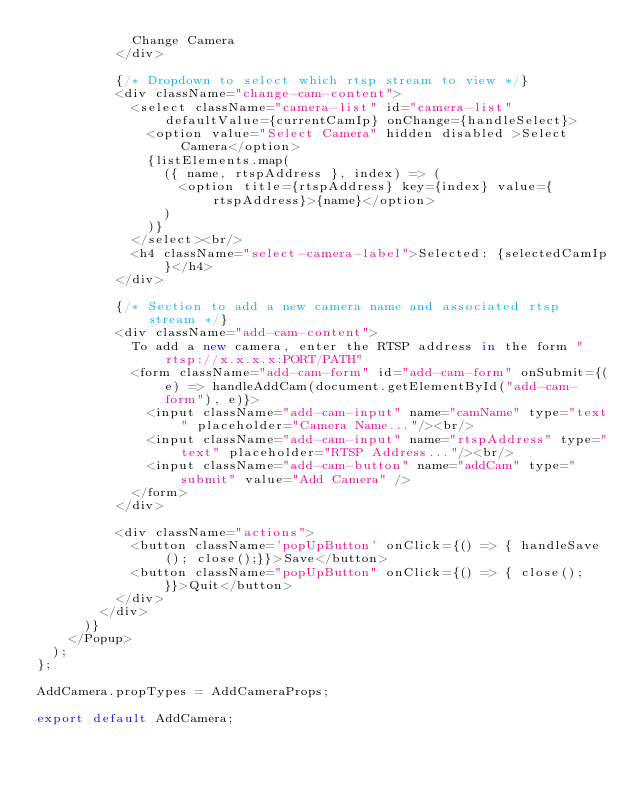<code> <loc_0><loc_0><loc_500><loc_500><_JavaScript_>            Change Camera
          </div>

          {/* Dropdown to select which rtsp stream to view */}
          <div className="change-cam-content">
            <select className="camera-list" id="camera-list" defaultValue={currentCamIp} onChange={handleSelect}>
              <option value="Select Camera" hidden disabled >Select Camera</option>
              {listElements.map(
                ({ name, rtspAddress }, index) => (
                  <option title={rtspAddress} key={index} value={rtspAddress}>{name}</option>
                )
              )}
            </select><br/>
            <h4 className="select-camera-label">Selected: {selectedCamIp}</h4>
          </div>

          {/* Section to add a new camera name and associated rtsp stream */}
          <div className="add-cam-content">
            To add a new camera, enter the RTSP address in the form "rtsp://x.x.x.x:PORT/PATH"
            <form className="add-cam-form" id="add-cam-form" onSubmit={(e) => handleAddCam(document.getElementById("add-cam-form"), e)}>
              <input className="add-cam-input" name="camName" type="text" placeholder="Camera Name..."/><br/>
              <input className="add-cam-input" name="rtspAddress" type="text" placeholder="RTSP Address..."/><br/>
              <input className="add-cam-button" name="addCam" type="submit" value="Add Camera" />
            </form>
          </div>

          <div className="actions">
            <button className='popUpButton' onClick={() => { handleSave(); close();}}>Save</button>
            <button className="popUpButton" onClick={() => { close(); }}>Quit</button>
          </div>
        </div>
      )}
    </Popup>
  );
};
  
AddCamera.propTypes = AddCameraProps;

export default AddCamera;</code> 